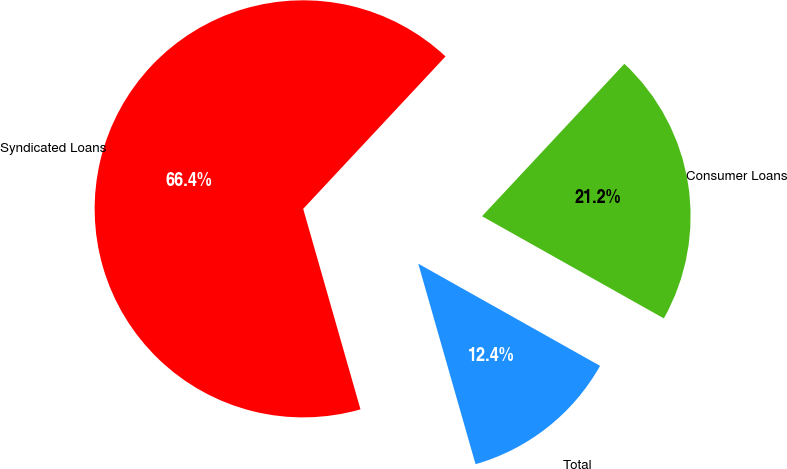<chart> <loc_0><loc_0><loc_500><loc_500><pie_chart><fcel>Total<fcel>Consumer Loans<fcel>Syndicated Loans<nl><fcel>12.42%<fcel>21.19%<fcel>66.38%<nl></chart> 